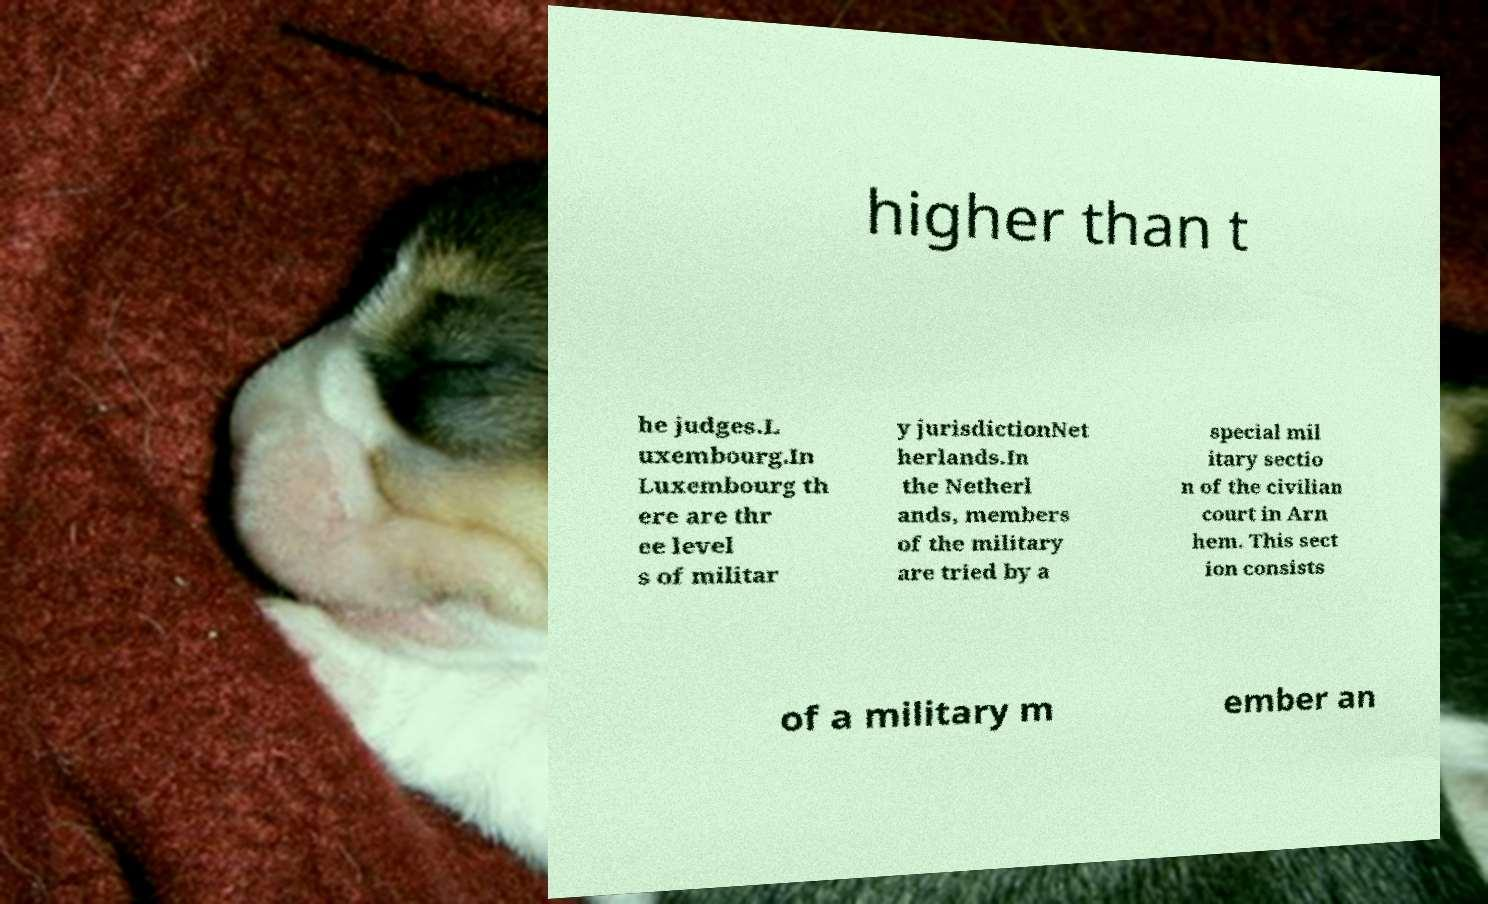Please identify and transcribe the text found in this image. higher than t he judges.L uxembourg.In Luxembourg th ere are thr ee level s of militar y jurisdictionNet herlands.In the Netherl ands, members of the military are tried by a special mil itary sectio n of the civilian court in Arn hem. This sect ion consists of a military m ember an 